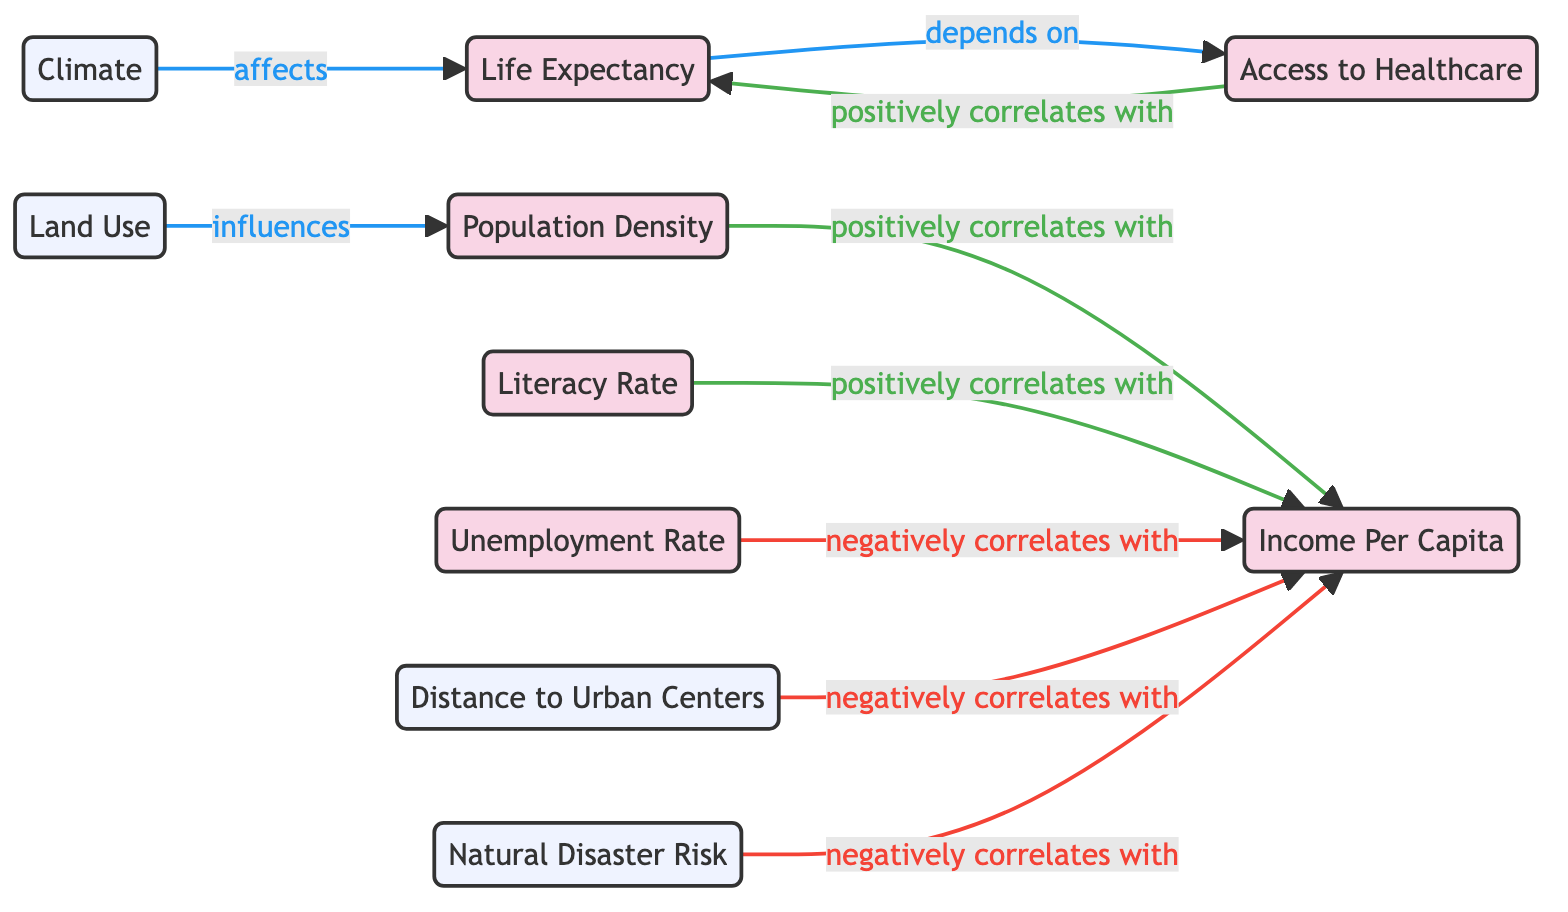What's the total number of socio-economic nodes in the diagram? The socio-economic nodes are Population Density, Income Per Capita, Literacy Rate, Unemployment Rate, Life Expectancy, and Access to Healthcare. Counting these gives us a total of six socio-economic nodes.
Answer: 6 What does Population Density positively correlate with? The diagram shows an arrow from Population Density to Income Per Capita labeled "positively correlates with," indicating that Population Density positively influences Income Per Capita.
Answer: Income Per Capita How does Life Expectancy depend on Access to Healthcare? The diagram indicates a connection from Access to Healthcare to Life Expectancy with the label "depends on." This signifies that improved access to healthcare is a determinant for better life expectancy.
Answer: Access to Healthcare What is the relationship between Distance to Urban Centers and Income Per Capita? The diagram specifies that Distance to Urban Centers negatively correlates with Income Per Capita, meaning that as the distance increases, Income Per Capita tends to decrease.
Answer: negatively correlates with Which geographic factor influences Population Density? From the diagram, Land Use has an arrow pointing to Population Density labeled "influences," meaning that the way land is utilized impacts the density of the population.
Answer: Land Use What color represents socio-economic nodes in the diagram? The socio-economic nodes are designated with a specific shade of pink (hex code #f9d5e5), distinguishing them from geographic factors which are represented in light blue.
Answer: Pink How many factors negatively correlate with Income Per Capita? Upon inspecting the diagram, Income Per Capita has three factors that show negative correlations: Unemployment Rate, Distance to Urban Centers, and Natural Disaster Risk. Counting these gives a total of three such factors.
Answer: 3 Which geographic factor affects Life Expectancy? The diagram shows a direct connection from Climate to Life Expectancy labeled "affects," which clearly indicates that climate conditions have implications for life expectancy rates.
Answer: Climate What is the overall relationship pattern between Income Per Capita and socio-economic factors? The pattern shows that Income Per Capita is positively influenced by Population Density and Literacy Rate, while it is negatively affected by Unemployment Rate, Distance to Urban Centers, and Natural Disaster Risk. This reflects a complex interplay of economic indicators.
Answer: Complex interplay 